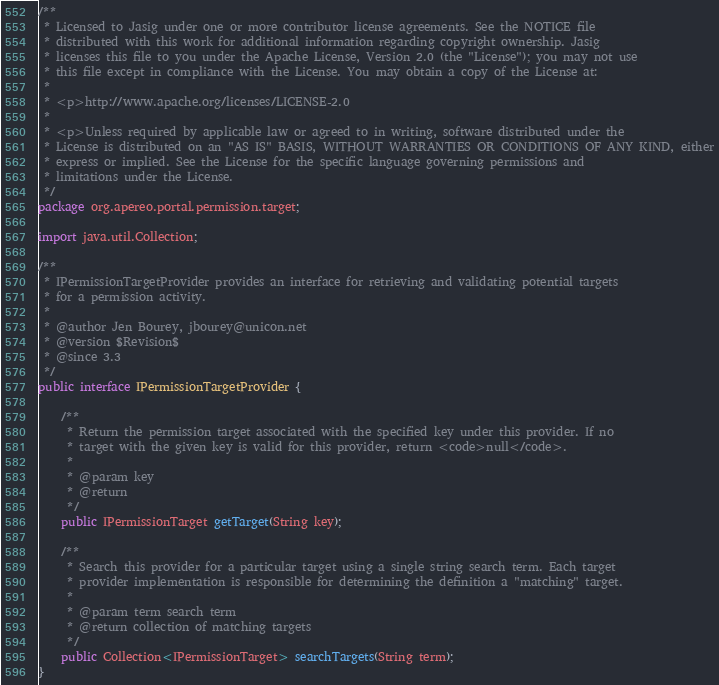Convert code to text. <code><loc_0><loc_0><loc_500><loc_500><_Java_>/**
 * Licensed to Jasig under one or more contributor license agreements. See the NOTICE file
 * distributed with this work for additional information regarding copyright ownership. Jasig
 * licenses this file to you under the Apache License, Version 2.0 (the "License"); you may not use
 * this file except in compliance with the License. You may obtain a copy of the License at:
 *
 * <p>http://www.apache.org/licenses/LICENSE-2.0
 *
 * <p>Unless required by applicable law or agreed to in writing, software distributed under the
 * License is distributed on an "AS IS" BASIS, WITHOUT WARRANTIES OR CONDITIONS OF ANY KIND, either
 * express or implied. See the License for the specific language governing permissions and
 * limitations under the License.
 */
package org.apereo.portal.permission.target;

import java.util.Collection;

/**
 * IPermissionTargetProvider provides an interface for retrieving and validating potential targets
 * for a permission activity.
 *
 * @author Jen Bourey, jbourey@unicon.net
 * @version $Revision$
 * @since 3.3
 */
public interface IPermissionTargetProvider {

    /**
     * Return the permission target associated with the specified key under this provider. If no
     * target with the given key is valid for this provider, return <code>null</code>.
     *
     * @param key
     * @return
     */
    public IPermissionTarget getTarget(String key);

    /**
     * Search this provider for a particular target using a single string search term. Each target
     * provider implementation is responsible for determining the definition a "matching" target.
     *
     * @param term search term
     * @return collection of matching targets
     */
    public Collection<IPermissionTarget> searchTargets(String term);
}
</code> 